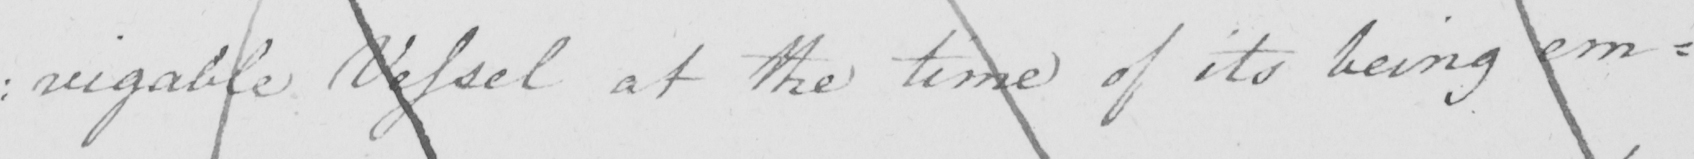What does this handwritten line say? : igable Vessel at the time of its being em= 